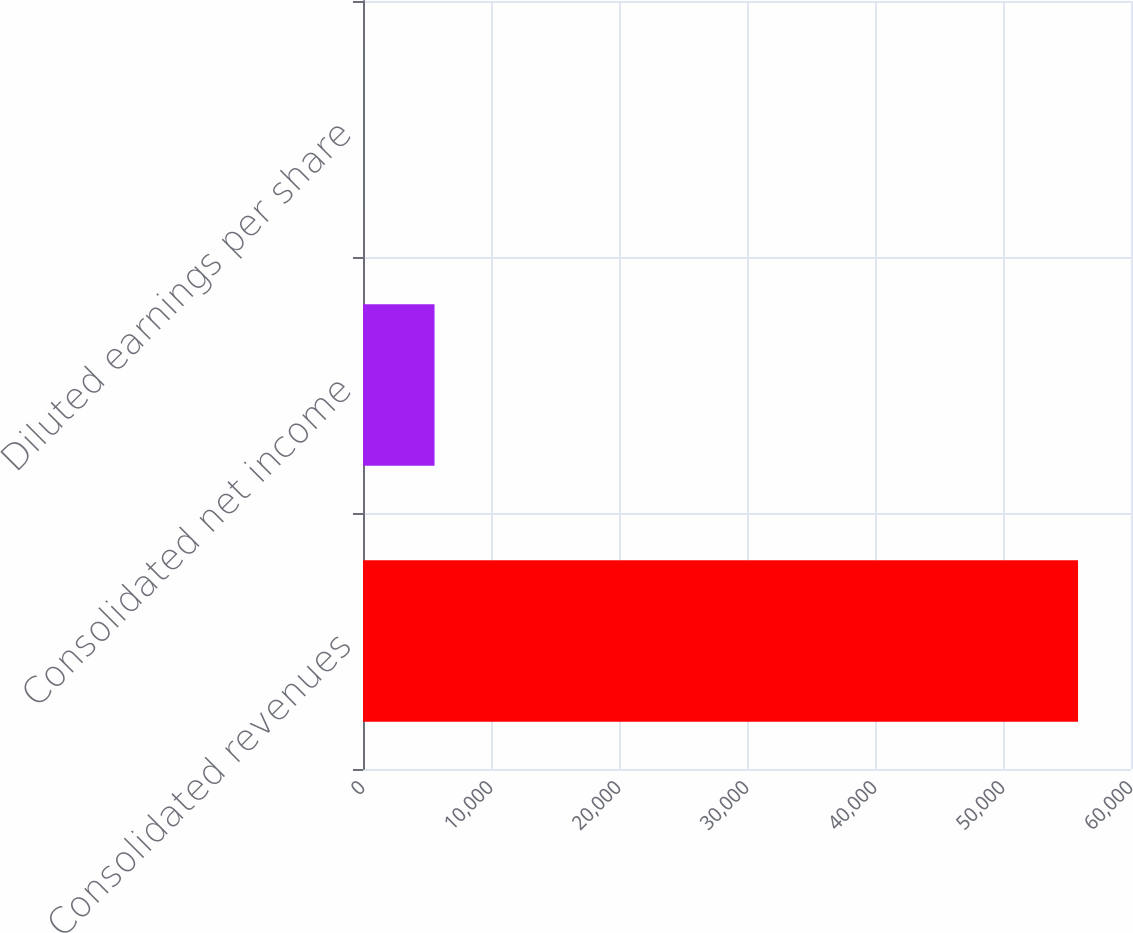Convert chart. <chart><loc_0><loc_0><loc_500><loc_500><bar_chart><fcel>Consolidated revenues<fcel>Consolidated net income<fcel>Diluted earnings per share<nl><fcel>55862<fcel>5588.2<fcel>2.22<nl></chart> 